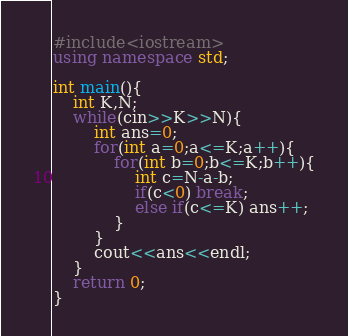Convert code to text. <code><loc_0><loc_0><loc_500><loc_500><_C++_>#include<iostream>
using namespace std;

int main(){
    int K,N;
    while(cin>>K>>N){
        int ans=0;
        for(int a=0;a<=K;a++){
            for(int b=0;b<=K;b++){
                int c=N-a-b;
                if(c<0) break;
                else if(c<=K) ans++;
            }
        }
        cout<<ans<<endl;
    }
    return 0;
}
</code> 